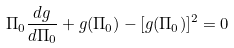Convert formula to latex. <formula><loc_0><loc_0><loc_500><loc_500>\Pi _ { 0 } \frac { d g } { d \Pi _ { 0 } } + g ( \Pi _ { 0 } ) - [ g ( \Pi _ { 0 } ) ] ^ { 2 } = 0</formula> 